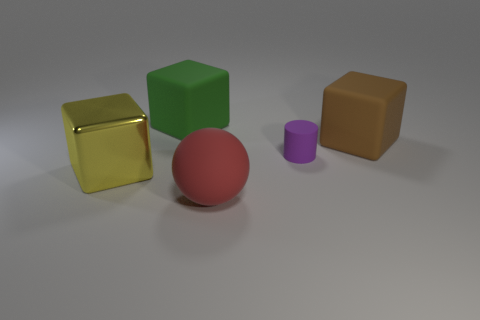There is a cube that is both in front of the large green matte cube and behind the large yellow metallic object; what is its color?
Your response must be concise. Brown. Is there a big cyan block that has the same material as the tiny object?
Give a very brief answer. No. What is the size of the metal block?
Your answer should be very brief. Large. There is a object in front of the big block in front of the purple rubber object; what size is it?
Provide a short and direct response. Large. What is the material of the yellow object that is the same shape as the large brown thing?
Provide a short and direct response. Metal. What number of small purple shiny cylinders are there?
Offer a very short reply. 0. There is a big object left of the matte thing on the left side of the big thing in front of the yellow thing; what color is it?
Your answer should be compact. Yellow. Is the number of brown matte cubes less than the number of tiny yellow matte spheres?
Keep it short and to the point. No. What is the color of the other big rubber object that is the same shape as the green object?
Your response must be concise. Brown. What color is the other block that is the same material as the large green cube?
Offer a very short reply. Brown. 